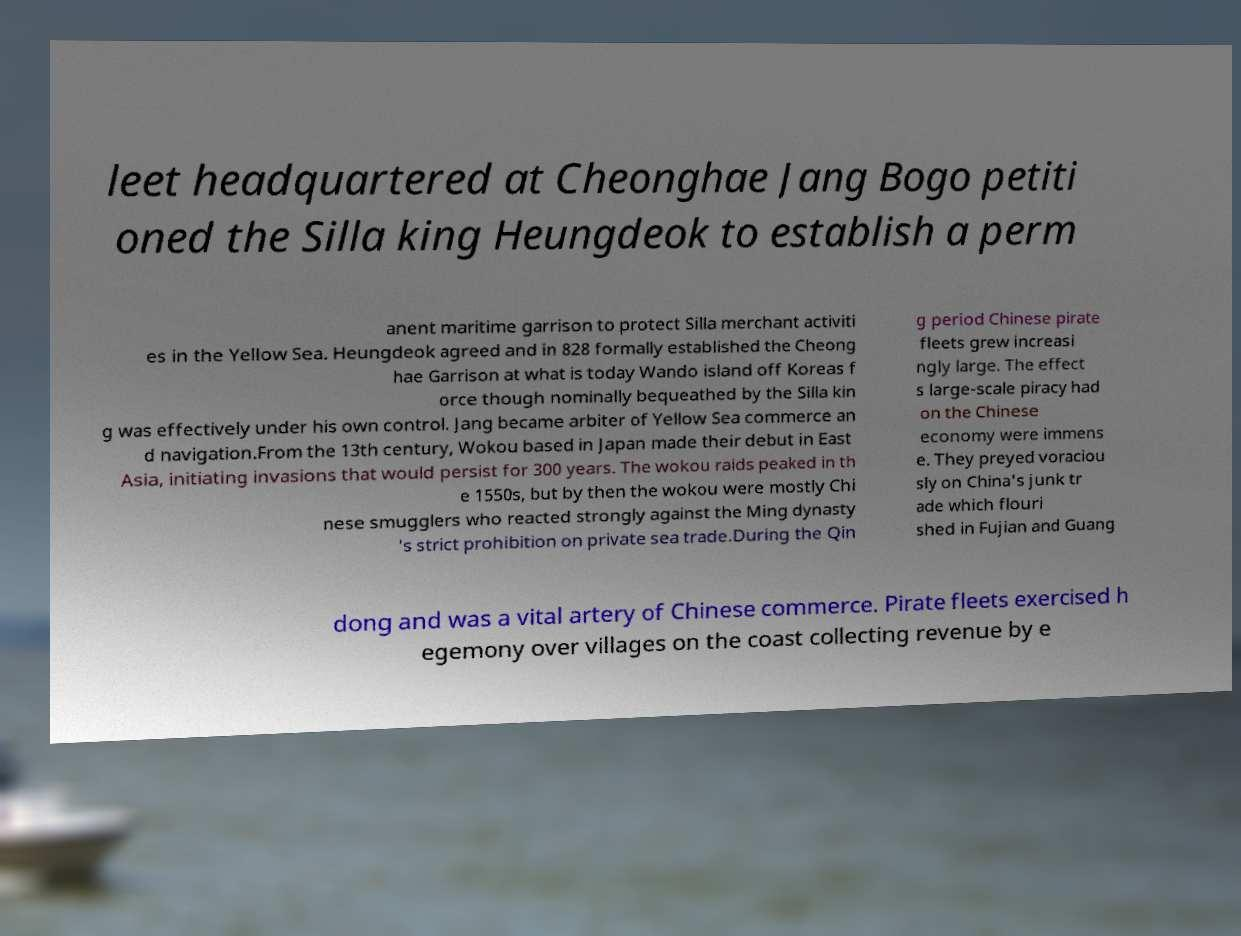Please identify and transcribe the text found in this image. leet headquartered at Cheonghae Jang Bogo petiti oned the Silla king Heungdeok to establish a perm anent maritime garrison to protect Silla merchant activiti es in the Yellow Sea. Heungdeok agreed and in 828 formally established the Cheong hae Garrison at what is today Wando island off Koreas f orce though nominally bequeathed by the Silla kin g was effectively under his own control. Jang became arbiter of Yellow Sea commerce an d navigation.From the 13th century, Wokou based in Japan made their debut in East Asia, initiating invasions that would persist for 300 years. The wokou raids peaked in th e 1550s, but by then the wokou were mostly Chi nese smugglers who reacted strongly against the Ming dynasty 's strict prohibition on private sea trade.During the Qin g period Chinese pirate fleets grew increasi ngly large. The effect s large-scale piracy had on the Chinese economy were immens e. They preyed voraciou sly on China's junk tr ade which flouri shed in Fujian and Guang dong and was a vital artery of Chinese commerce. Pirate fleets exercised h egemony over villages on the coast collecting revenue by e 